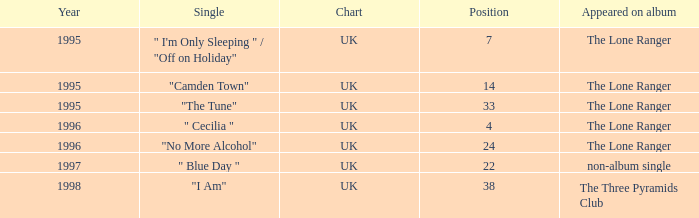Following 1996, what is the mean position? 30.0. 